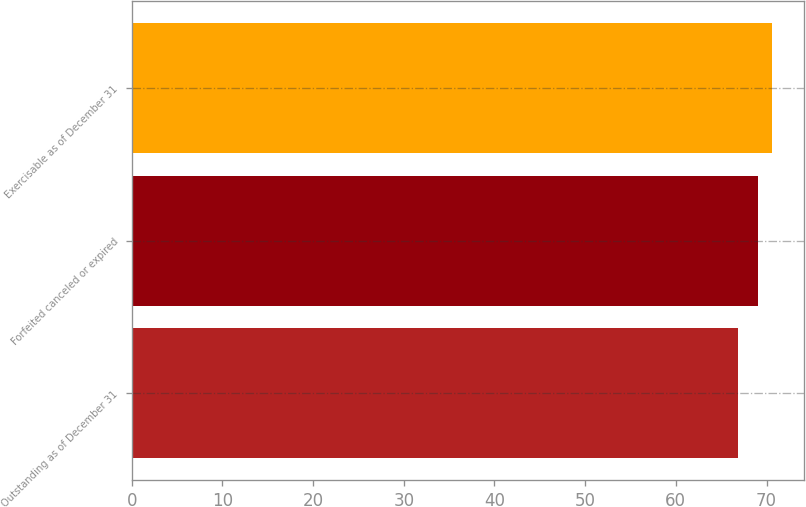<chart> <loc_0><loc_0><loc_500><loc_500><bar_chart><fcel>Outstanding as of December 31<fcel>Forfeited canceled or expired<fcel>Exercisable as of December 31<nl><fcel>66.83<fcel>69.03<fcel>70.57<nl></chart> 